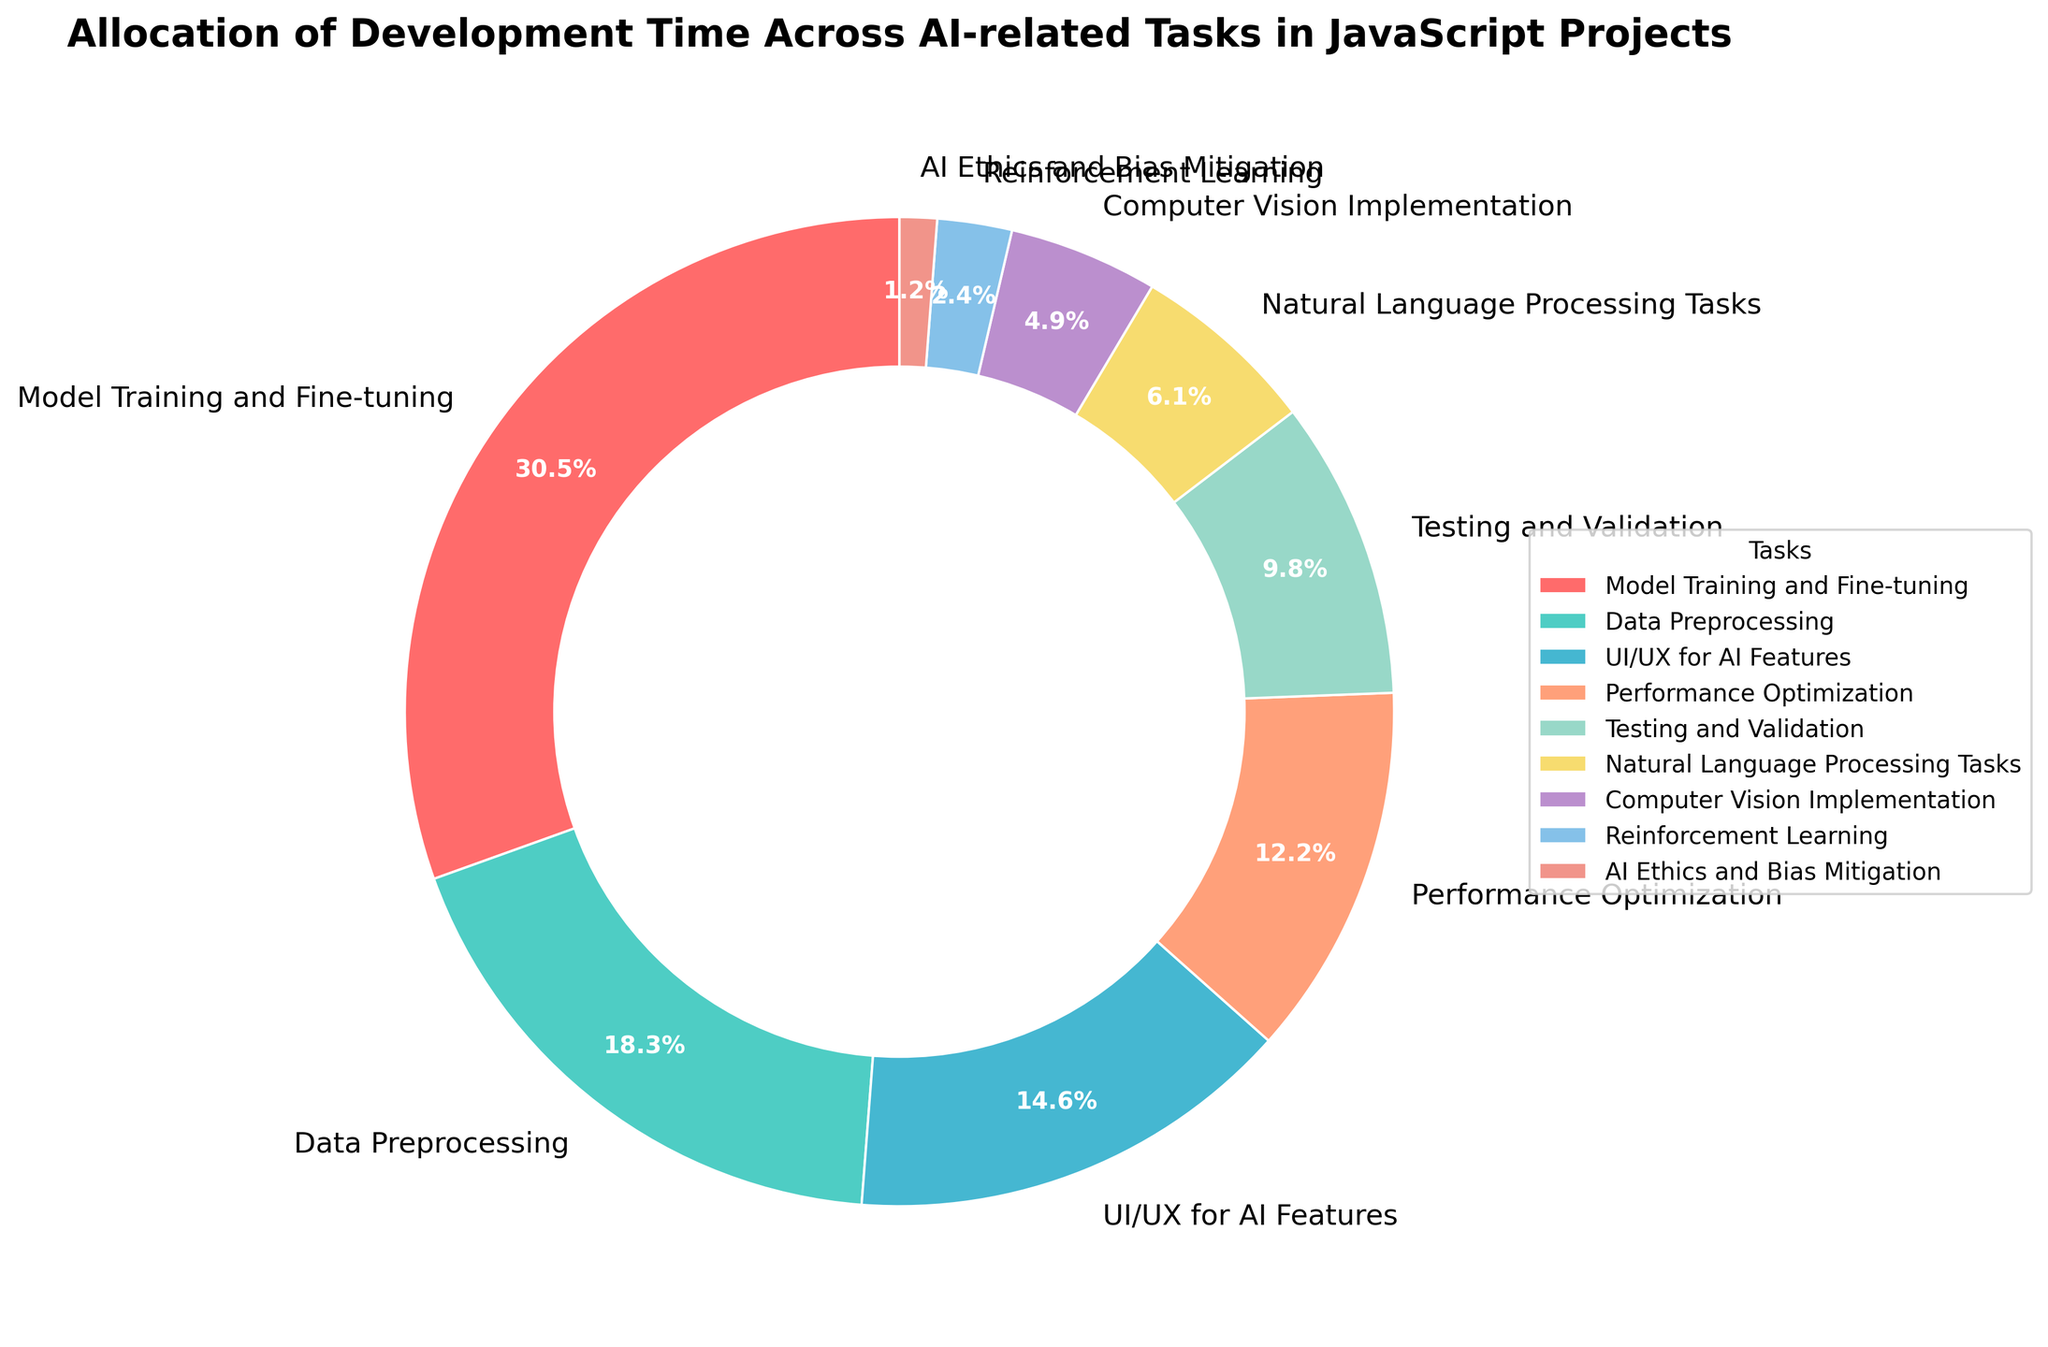Which task takes up the largest percentage of development time? The task labeled "Model Training and Fine-tuning" has the largest percentage, which is 25%.
Answer: Model Training and Fine-tuning What is the total percentage of time spent on Data Preprocessing and Performance Optimization? The percentages for Data Preprocessing and Performance Optimization are 15% and 10%, respectively. Adding these gives 15 + 10 = 25%.
Answer: 25% Is more time spent on Testing and Validation or UI/UX for AI Features? The pie chart shows that Testing and Validation takes 8%, while UI/UX for AI Features takes 12%. Since 8% is less than 12%, more time is spent on UI/UX for AI Features.
Answer: UI/UX for AI Features Which tasks combined take up the least amount of development time? The smallest slices are for Reinforcement Learning (2%) and AI Ethics and Bias Mitigation (1%). Combined, they take up 2 + 1 = 3%.
Answer: Reinforcement Learning and AI Ethics and Bias Mitigation What is the percentage difference between the time spent on Natural Language Processing Tasks and Computer Vision Implementation? The percentages for Natural Language Processing Tasks and Computer Vision Implementation are 5% and 4%, respectively. The difference is 5 - 4 = 1%.
Answer: 1% Which color represents Model Training and Fine-tuning in the pie chart? The largest slice, which represents Model Training and Fine-tuning (25%), is colored red.
Answer: red How much more time is spent on Data Preprocessing than on Natural Language Processing Tasks? Data Preprocessing takes 15%, and Natural Language Processing Tasks take 5%. The difference is 15 - 5 = 10%.
Answer: 10% Which three tasks combined make up half of the total development time? The top three tasks in terms of percentage are Model Training and Fine-tuning (25%), Data Preprocessing (15%), and UI/UX for AI Features (12%). Together, they sum to 25 + 15 + 12 = 52%, which is more than 50%.
Answer: Model Training and Fine-tuning, Data Preprocessing, and UI/UX for AI Features 